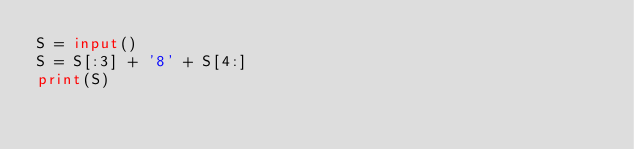Convert code to text. <code><loc_0><loc_0><loc_500><loc_500><_Python_>S = input()
S = S[:3] + '8' + S[4:]
print(S)</code> 